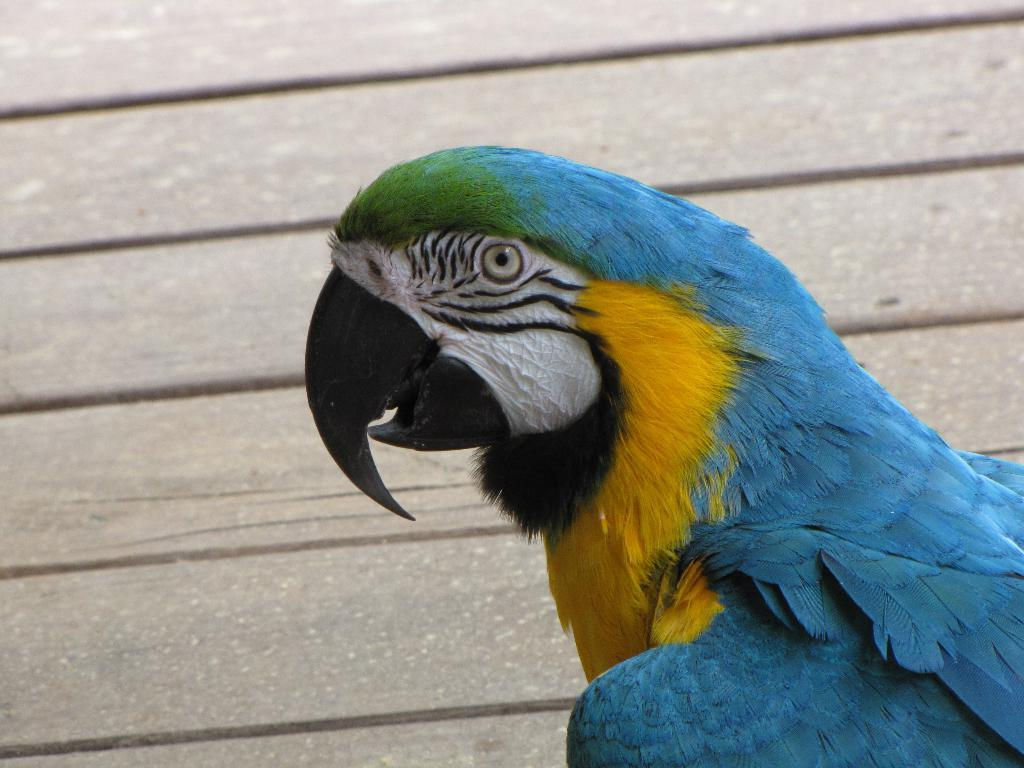What type of animal can be seen in the image? There is a bird in the image. What is the bird standing on or near in the image? There is a wooden platform in the background of the image. How does the bird breathe in the image? The bird's breathing is not visible in the image, and it is not possible to determine how it breathes based on the image alone. 